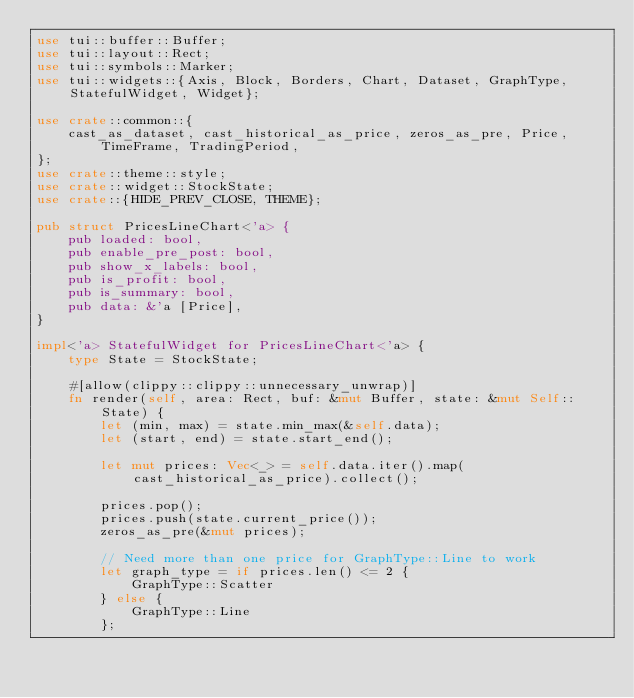Convert code to text. <code><loc_0><loc_0><loc_500><loc_500><_Rust_>use tui::buffer::Buffer;
use tui::layout::Rect;
use tui::symbols::Marker;
use tui::widgets::{Axis, Block, Borders, Chart, Dataset, GraphType, StatefulWidget, Widget};

use crate::common::{
    cast_as_dataset, cast_historical_as_price, zeros_as_pre, Price, TimeFrame, TradingPeriod,
};
use crate::theme::style;
use crate::widget::StockState;
use crate::{HIDE_PREV_CLOSE, THEME};

pub struct PricesLineChart<'a> {
    pub loaded: bool,
    pub enable_pre_post: bool,
    pub show_x_labels: bool,
    pub is_profit: bool,
    pub is_summary: bool,
    pub data: &'a [Price],
}

impl<'a> StatefulWidget for PricesLineChart<'a> {
    type State = StockState;

    #[allow(clippy::clippy::unnecessary_unwrap)]
    fn render(self, area: Rect, buf: &mut Buffer, state: &mut Self::State) {
        let (min, max) = state.min_max(&self.data);
        let (start, end) = state.start_end();

        let mut prices: Vec<_> = self.data.iter().map(cast_historical_as_price).collect();

        prices.pop();
        prices.push(state.current_price());
        zeros_as_pre(&mut prices);

        // Need more than one price for GraphType::Line to work
        let graph_type = if prices.len() <= 2 {
            GraphType::Scatter
        } else {
            GraphType::Line
        };
</code> 